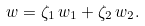Convert formula to latex. <formula><loc_0><loc_0><loc_500><loc_500>w = \zeta _ { 1 } \, w _ { 1 } + \zeta _ { 2 } \, w _ { 2 } .</formula> 